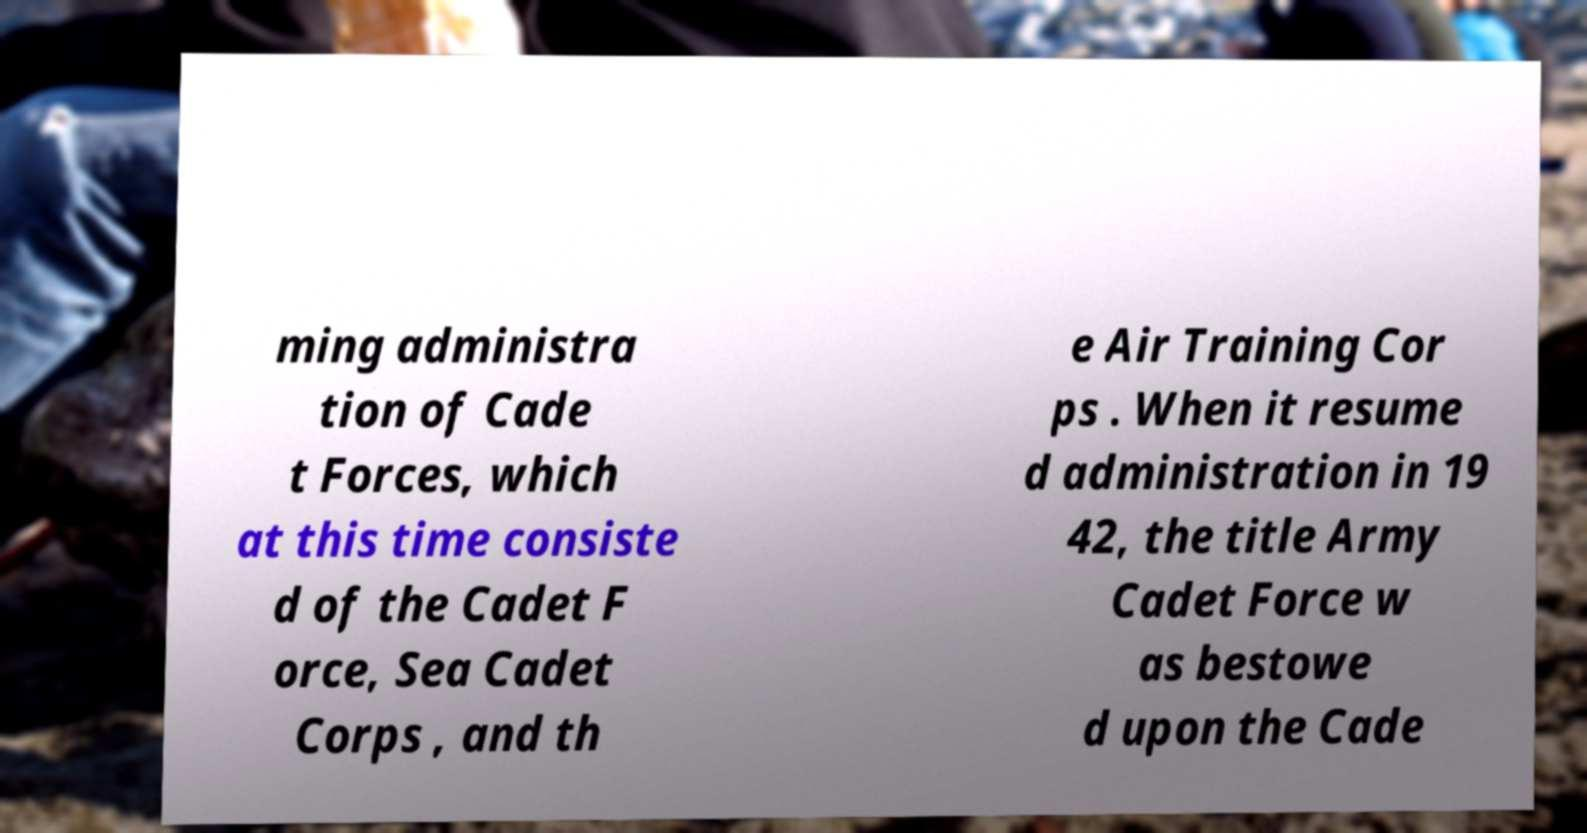What messages or text are displayed in this image? I need them in a readable, typed format. ming administra tion of Cade t Forces, which at this time consiste d of the Cadet F orce, Sea Cadet Corps , and th e Air Training Cor ps . When it resume d administration in 19 42, the title Army Cadet Force w as bestowe d upon the Cade 